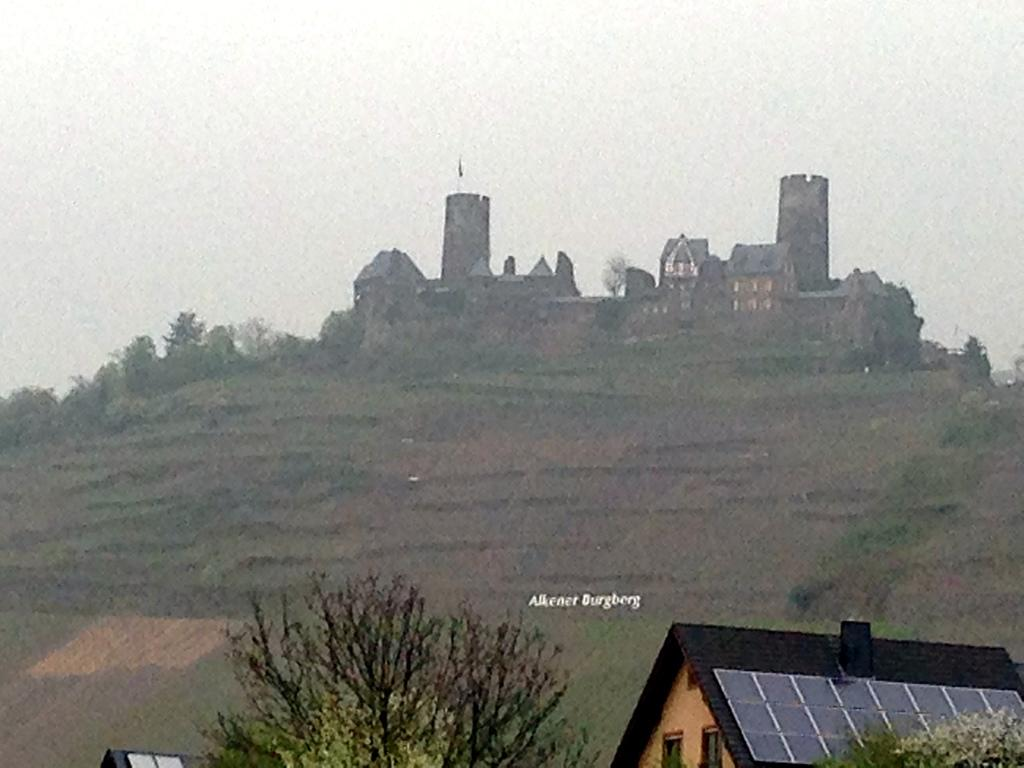What type of vegetation can be seen in the image? There are trees in the image. What kind of structure is present in the image? There is a wooden house in the image. What type of terrain is visible in the image? There are hills in the image. Are there any other structures besides the wooden house? Yes, there are additional buildings in the image. What else can be seen in the image? There is text visible in the image. What is visible in the background of the image? The sky is visible in the background of the image. What type of paint is being used by the lawyer on holiday in the image? There is no lawyer or holiday depicted in the image, and therefore no paint or painting activity can be observed. 